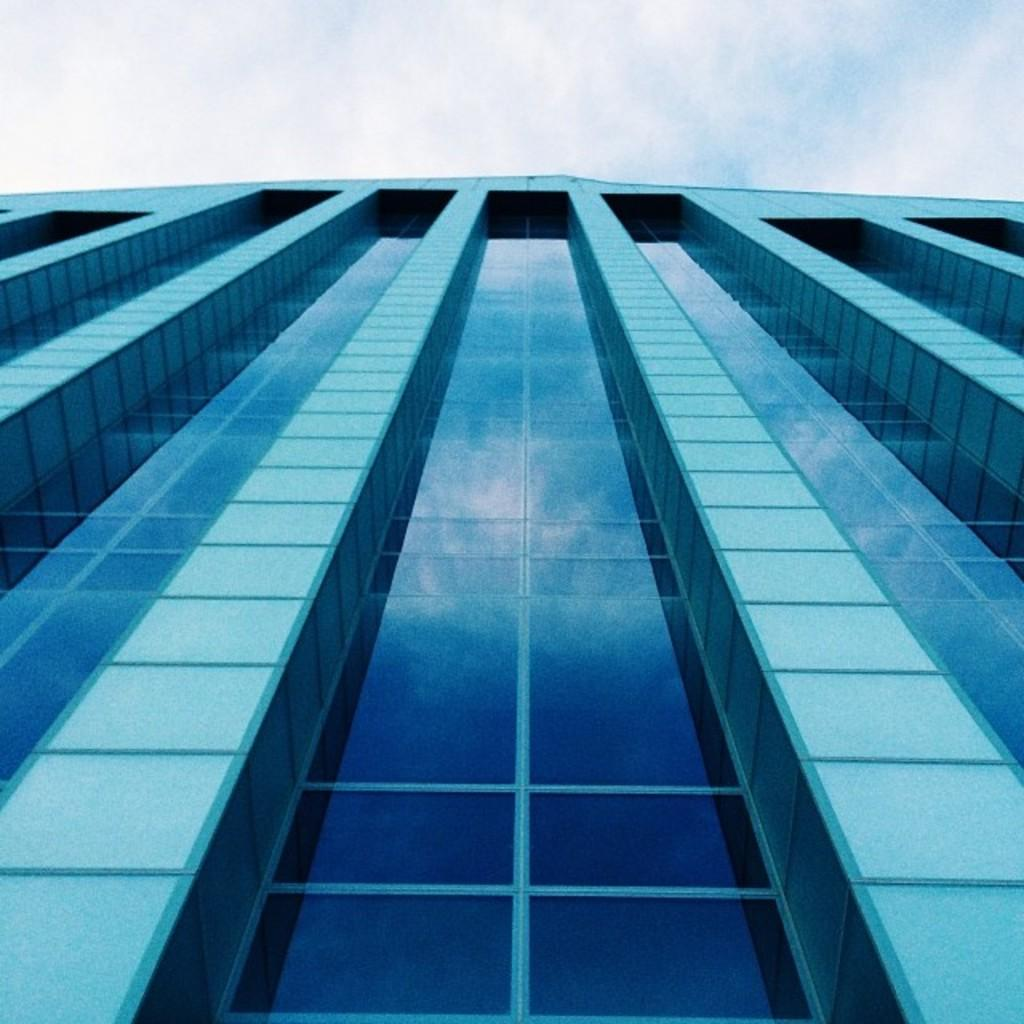What type of structure is present in the image? There is a building in the image. What can be seen in the background of the image? The sky is visible in the background of the image. How would you describe the sky in the image? The sky appears to be cloudy. Where is the bucket located in the image? There is no bucket present in the image. What type of work is being done in the image? There is no indication of any work being done in the image. 